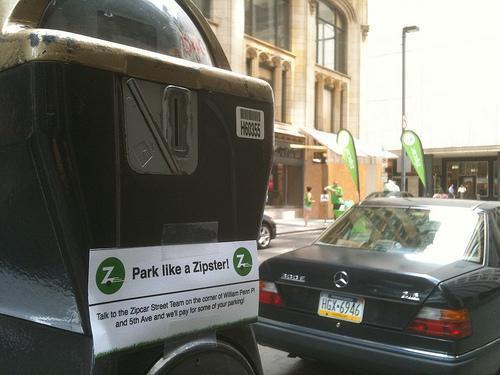How many cars can at least be partially seen?
Give a very brief answer. 2. How many parking meters are visible?
Give a very brief answer. 1. 